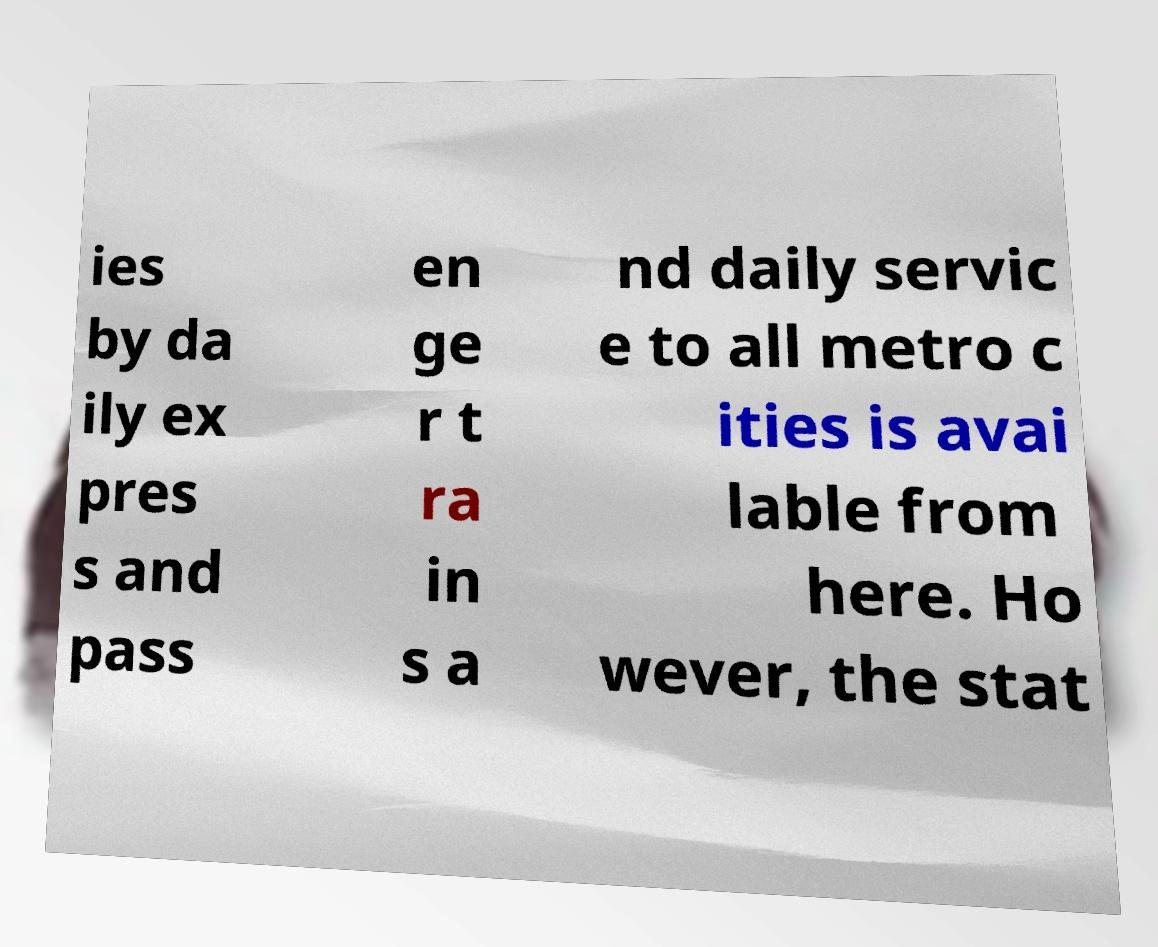Can you read and provide the text displayed in the image?This photo seems to have some interesting text. Can you extract and type it out for me? ies by da ily ex pres s and pass en ge r t ra in s a nd daily servic e to all metro c ities is avai lable from here. Ho wever, the stat 